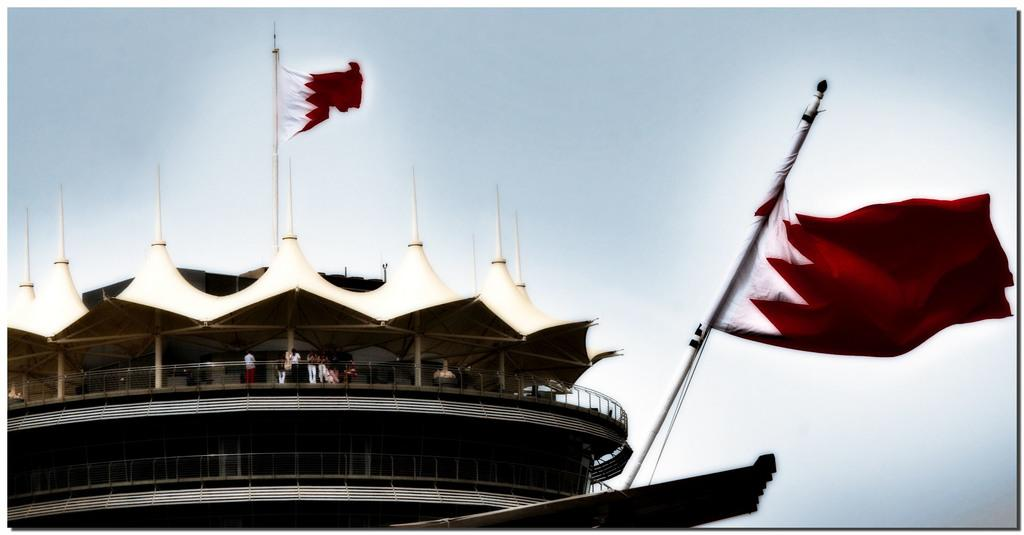What are the people in the image doing? The people in the image are standing on a building. What else can be seen in the image besides the people? Flags are visible in the image. What type of waves can be seen crashing against the steel structure in the image? There is no steel structure or waves present in the image; it features people standing on a building with flags. 